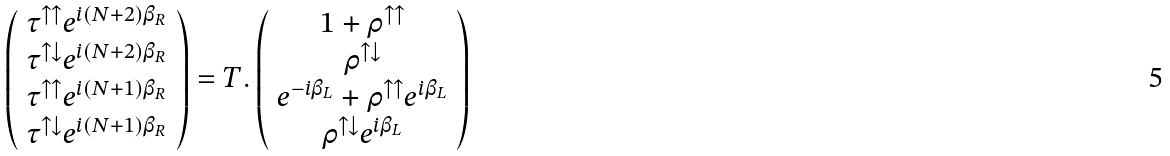<formula> <loc_0><loc_0><loc_500><loc_500>\left ( \begin{array} { c } \tau ^ { \uparrow \uparrow } e ^ { i ( N + 2 ) \beta _ { R } } \\ \tau ^ { \uparrow \downarrow } e ^ { i ( N + 2 ) \beta _ { R } } \\ \tau ^ { \uparrow \uparrow } e ^ { i ( N + 1 ) \beta _ { R } } \\ \tau ^ { \uparrow \downarrow } e ^ { i ( N + 1 ) \beta _ { R } } \end{array} \right ) = T . \left ( \begin{array} { c } 1 + \rho ^ { \uparrow \uparrow } \\ \rho ^ { \uparrow \downarrow } \\ e ^ { - i \beta _ { L } } + \rho ^ { \uparrow \uparrow } e ^ { i \beta _ { L } } \\ \rho ^ { \uparrow \downarrow } e ^ { i \beta _ { L } } \end{array} \right )</formula> 